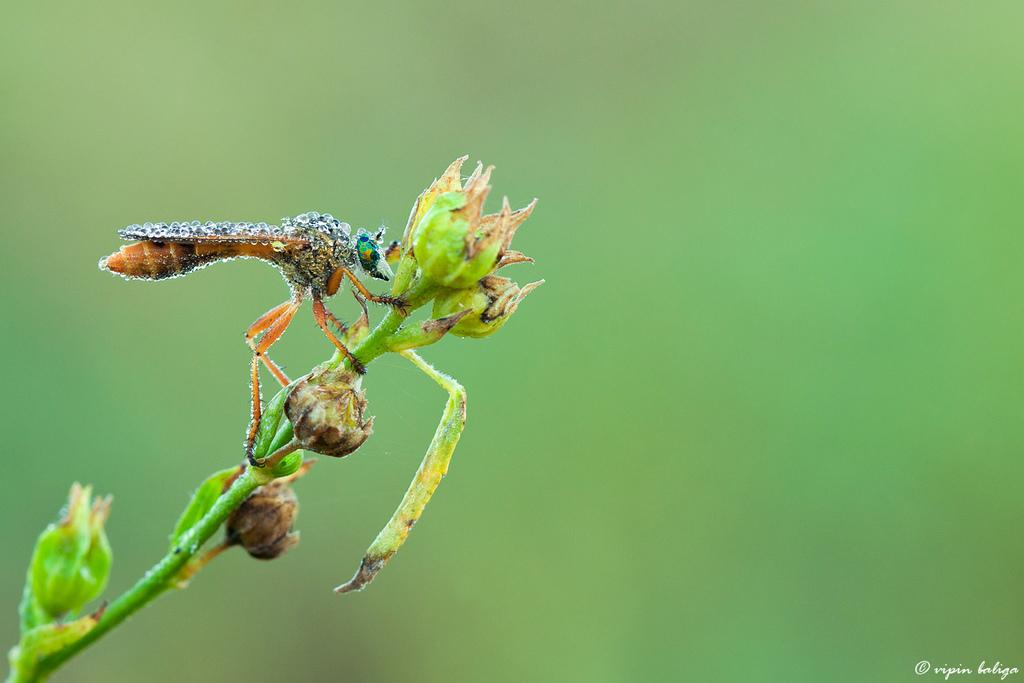What is located on a stem of a plant in the image? There is an insect on a stem of a plant in the image. What can be seen on the plant besides the insect? There are buds visible in the image. Where is the text located in the image? The text is in the bottom right corner of the image. What type of heat source can be seen in the image? There is no heat source present in the image. How many things are on the tray in the image? There is no tray present in the image. 